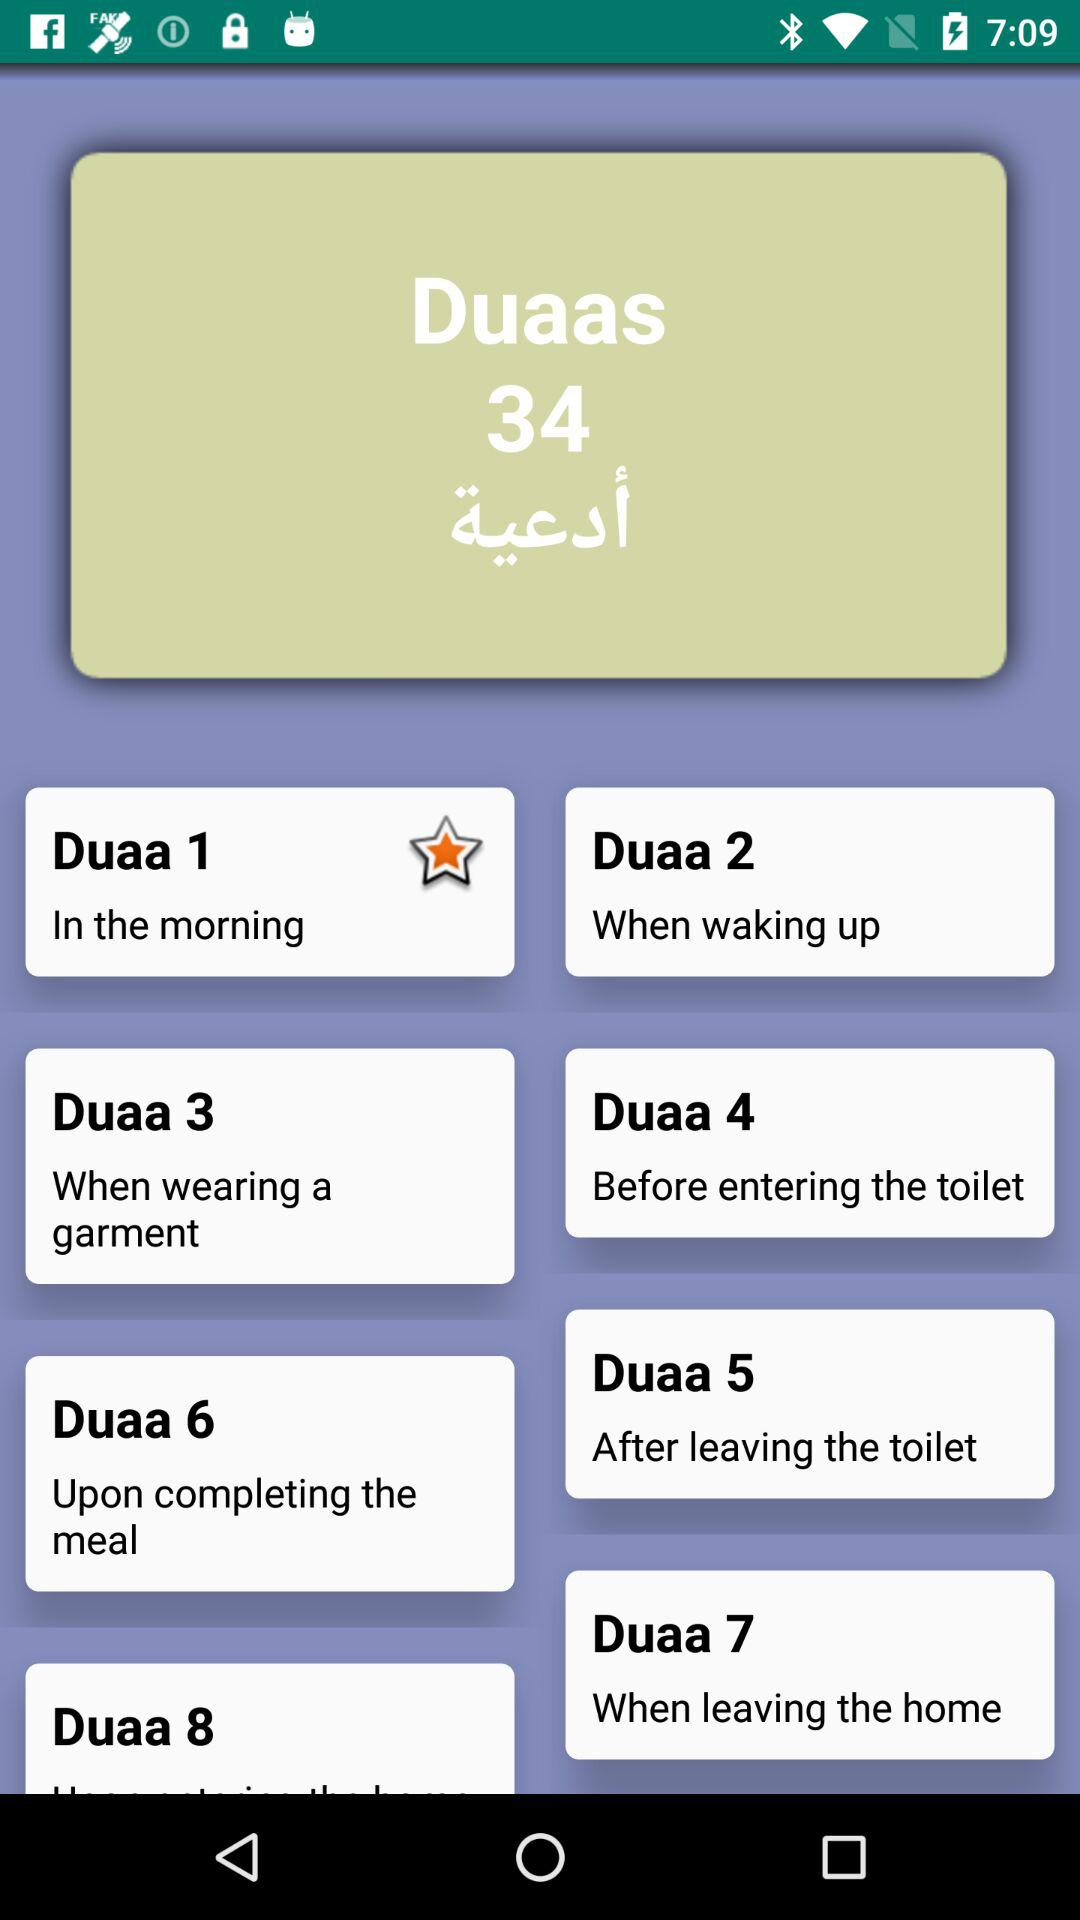Which duaa is currently starred? The duaa that is currently starred is "Duaa 1". 